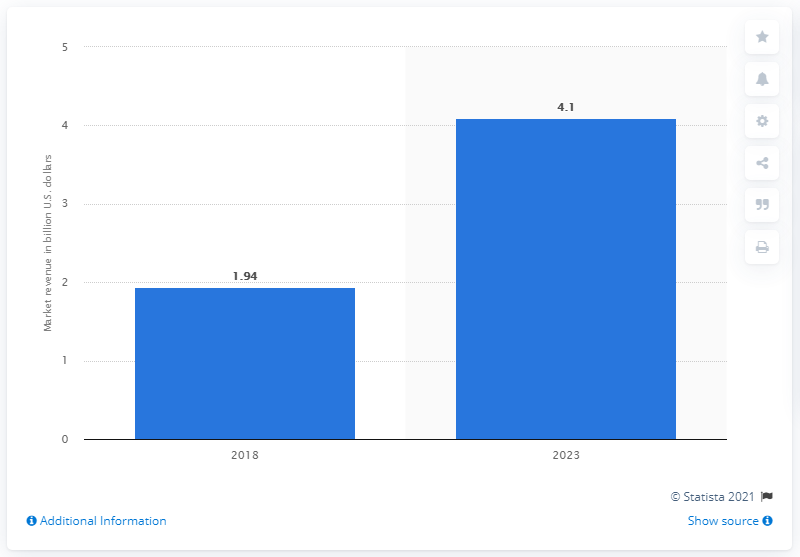Indicate a few pertinent items in this graphic. The DDoS protection and mitigation market was projected to grow to 4.1 billion USD in 2023. It is projected that the global DDoS protection and mitigation market will grow to 4.1 billion U.S. dollars in the year 2023. 